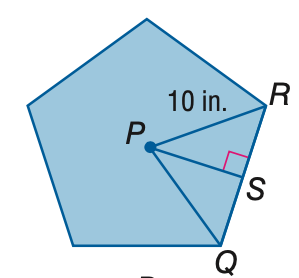Question: Find the area of the regular polygon. Round to the nearest tenth.
Choices:
A. 47.6
B. 118.9
C. 237.8
D. 475.6
Answer with the letter. Answer: C 